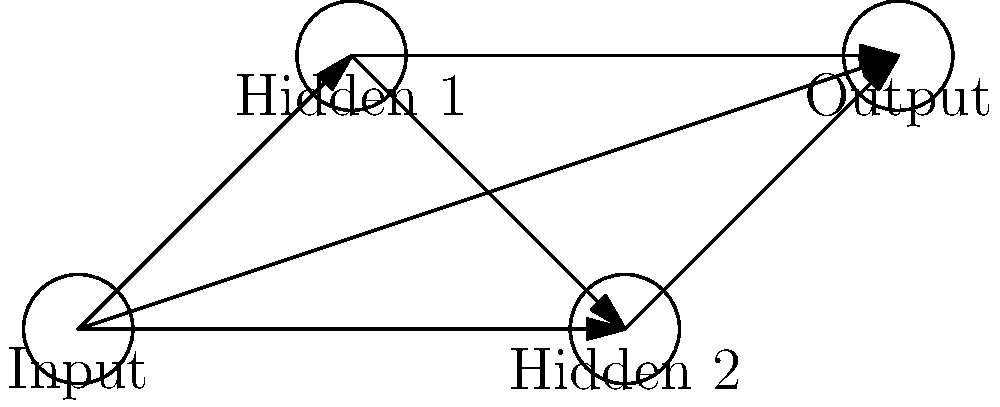Given the neural network architecture diagram above, what is the minimum number of weight matrices required to fully connect this network, and what are their dimensions? Assume the input layer has 3 neurons, each hidden layer has 4 neurons, and the output layer has 2 neurons. Let's approach this step-by-step:

1. First, we need to identify the layers in the network:
   - Input layer (3 neurons)
   - Hidden layer 1 (4 neurons)
   - Hidden layer 2 (4 neurons)
   - Output layer (2 neurons)

2. To fully connect this network, we need weight matrices between each adjacent pair of layers:
   - Input to Hidden 1
   - Hidden 1 to Hidden 2
   - Hidden 2 to Output

3. Now, let's determine the dimensions of each weight matrix:
   - Input to Hidden 1: This matrix connects 3 input neurons to 4 neurons in Hidden 1.
     Dimension: $4 \times 3$
   
   - Hidden 1 to Hidden 2: This matrix connects 4 neurons in Hidden 1 to 4 neurons in Hidden 2.
     Dimension: $4 \times 4$
   
   - Hidden 2 to Output: This matrix connects 4 neurons in Hidden 2 to 2 output neurons.
     Dimension: $2 \times 4$

4. Count the number of weight matrices: We have identified 3 weight matrices.

Therefore, the minimum number of weight matrices required is 3, with dimensions $4 \times 3$, $4 \times 4$, and $2 \times 4$.
Answer: 3 matrices: $4 \times 3$, $4 \times 4$, $2 \times 4$ 